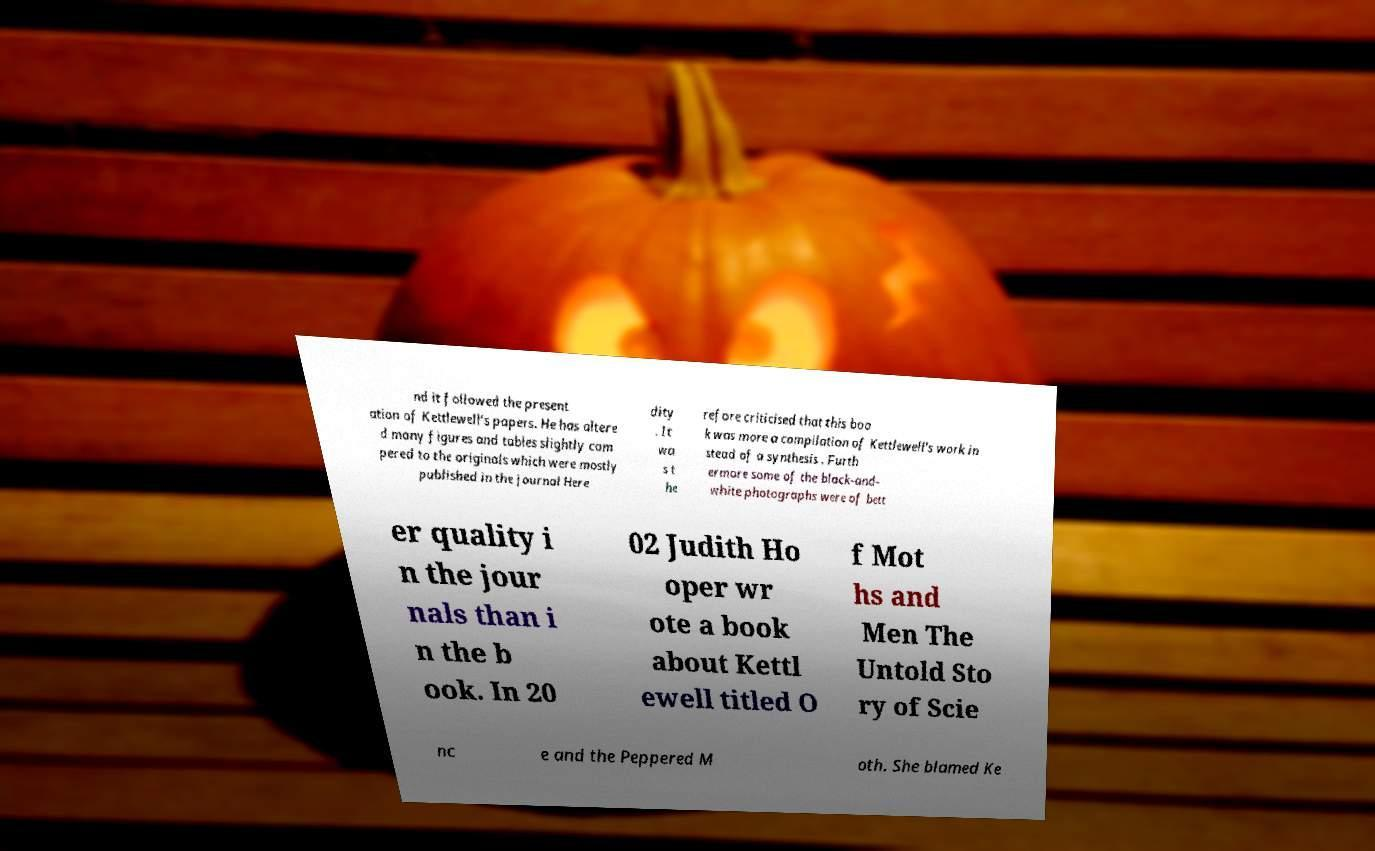Could you extract and type out the text from this image? nd it followed the present ation of Kettlewell’s papers. He has altere d many figures and tables slightly com pered to the originals which were mostly published in the journal Here dity . It wa s t he refore criticised that this boo k was more a compilation of Kettlewell’s work in stead of a synthesis . Furth ermore some of the black-and- white photographs were of bett er quality i n the jour nals than i n the b ook. In 20 02 Judith Ho oper wr ote a book about Kettl ewell titled O f Mot hs and Men The Untold Sto ry of Scie nc e and the Peppered M oth. She blamed Ke 